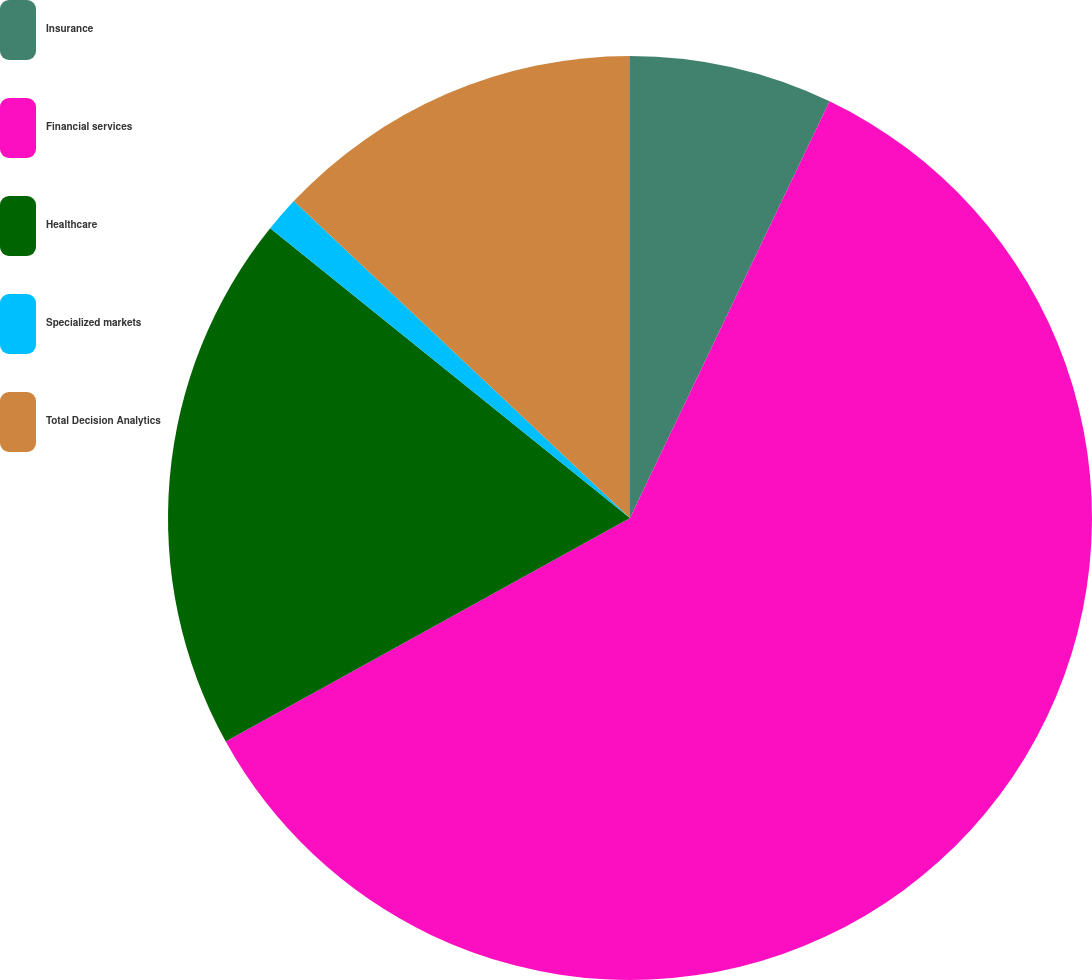Convert chart. <chart><loc_0><loc_0><loc_500><loc_500><pie_chart><fcel>Insurance<fcel>Financial services<fcel>Healthcare<fcel>Specialized markets<fcel>Total Decision Analytics<nl><fcel>7.11%<fcel>59.85%<fcel>18.83%<fcel>1.24%<fcel>12.97%<nl></chart> 